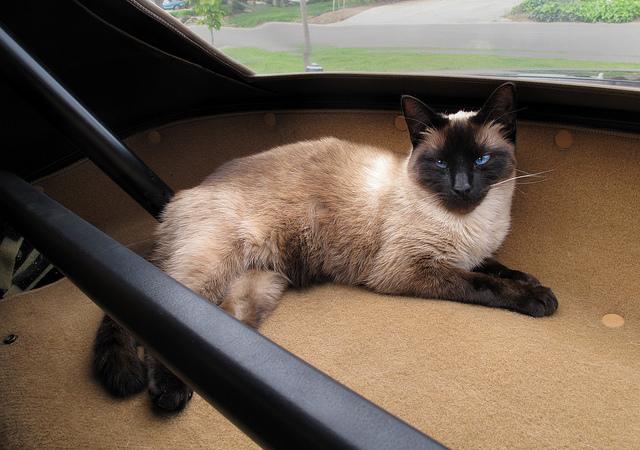Is animal laying in a car or outdoors?
Concise answer only. Car. What color are the cats eyes?
Answer briefly. Blue. What breed is this cat?
Concise answer only. Siamese. 